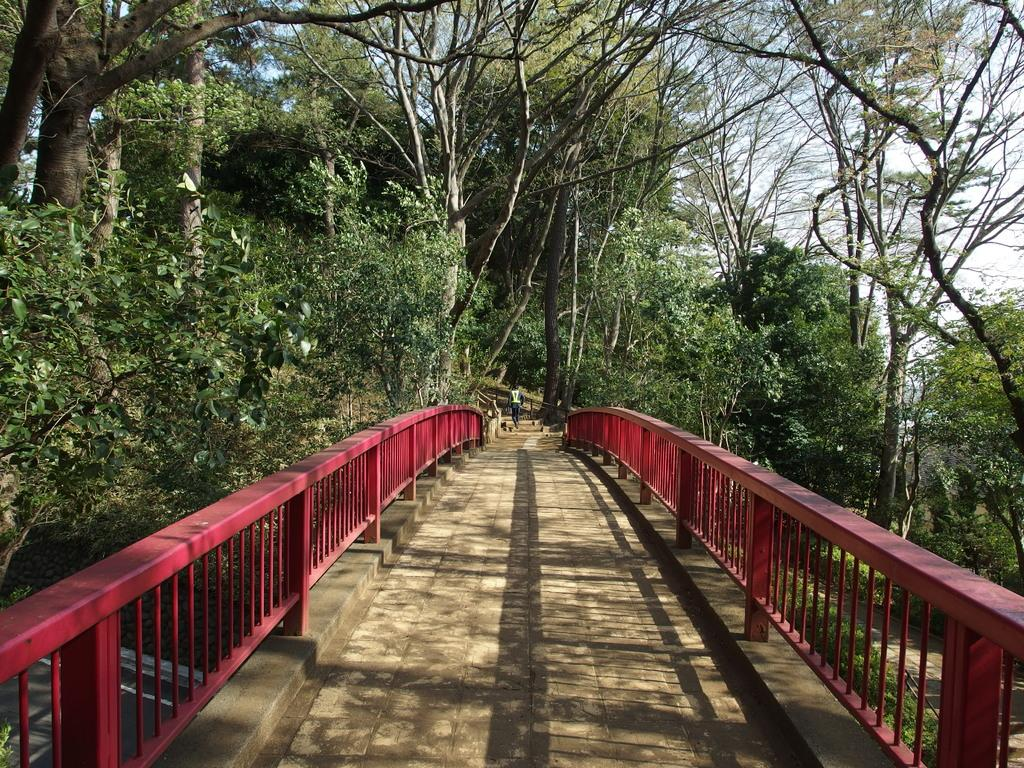What is the main structure in the center of the image? There is a bridge in the center of the image. Can you describe any other elements in the image? There is a person in the image, and there are trees and a road visible in the background. What type of van can be seen parked near the bridge in the image? There is no van present in the image; it only features a bridge, a person, trees, and a road in the background. 